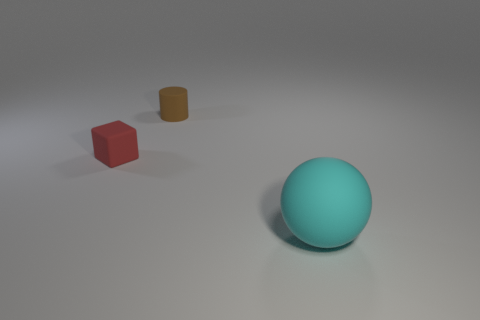Is the number of yellow cylinders greater than the number of brown rubber cylinders?
Ensure brevity in your answer.  No. What number of spheres have the same material as the large object?
Your answer should be very brief. 0. Is the shape of the small red matte thing the same as the big cyan thing?
Your response must be concise. No. There is a rubber object that is on the right side of the small thing on the right side of the tiny matte object in front of the tiny cylinder; what is its size?
Your answer should be very brief. Large. There is a tiny matte thing that is in front of the small rubber cylinder; are there any tiny objects behind it?
Provide a succinct answer. Yes. There is a small thing that is to the left of the matte object behind the red block; what number of tiny red rubber blocks are behind it?
Give a very brief answer. 0. What color is the object that is both in front of the tiny brown matte object and on the right side of the tiny cube?
Provide a short and direct response. Cyan. What number of large rubber things are the same color as the rubber block?
Offer a very short reply. 0. What number of cylinders are big cyan things or red rubber objects?
Your answer should be very brief. 0. There is a matte cube that is the same size as the rubber cylinder; what is its color?
Provide a succinct answer. Red. 